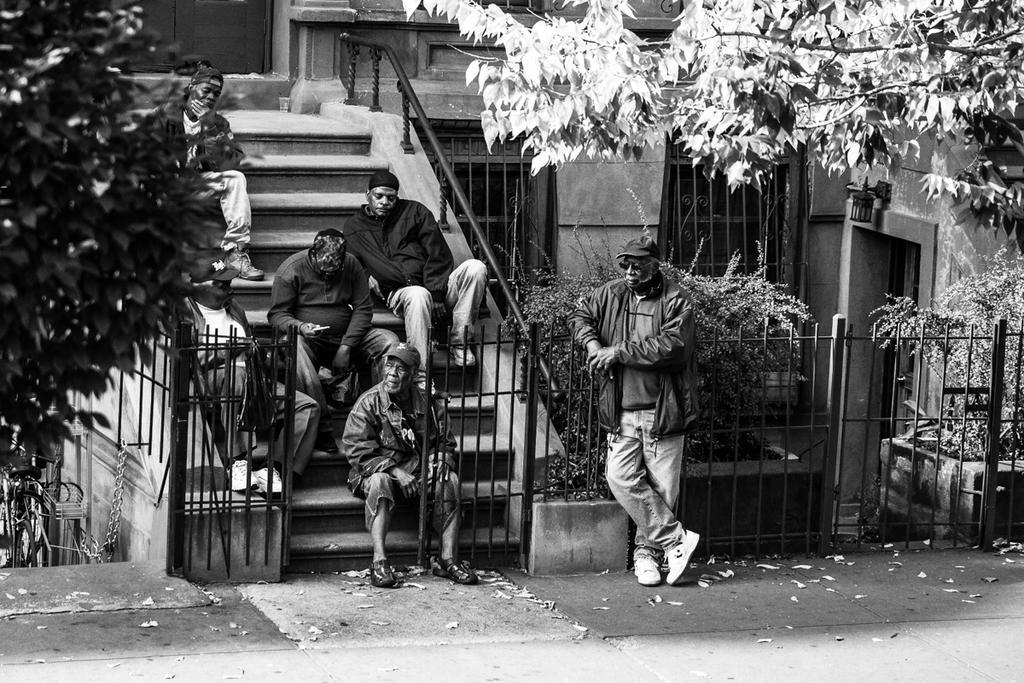In one or two sentences, can you explain what this image depicts? In this picture we can see a road, beside this road we can see a building and some people are sitting on steps and one person is standing, here we can see a fence, plants and trees. 